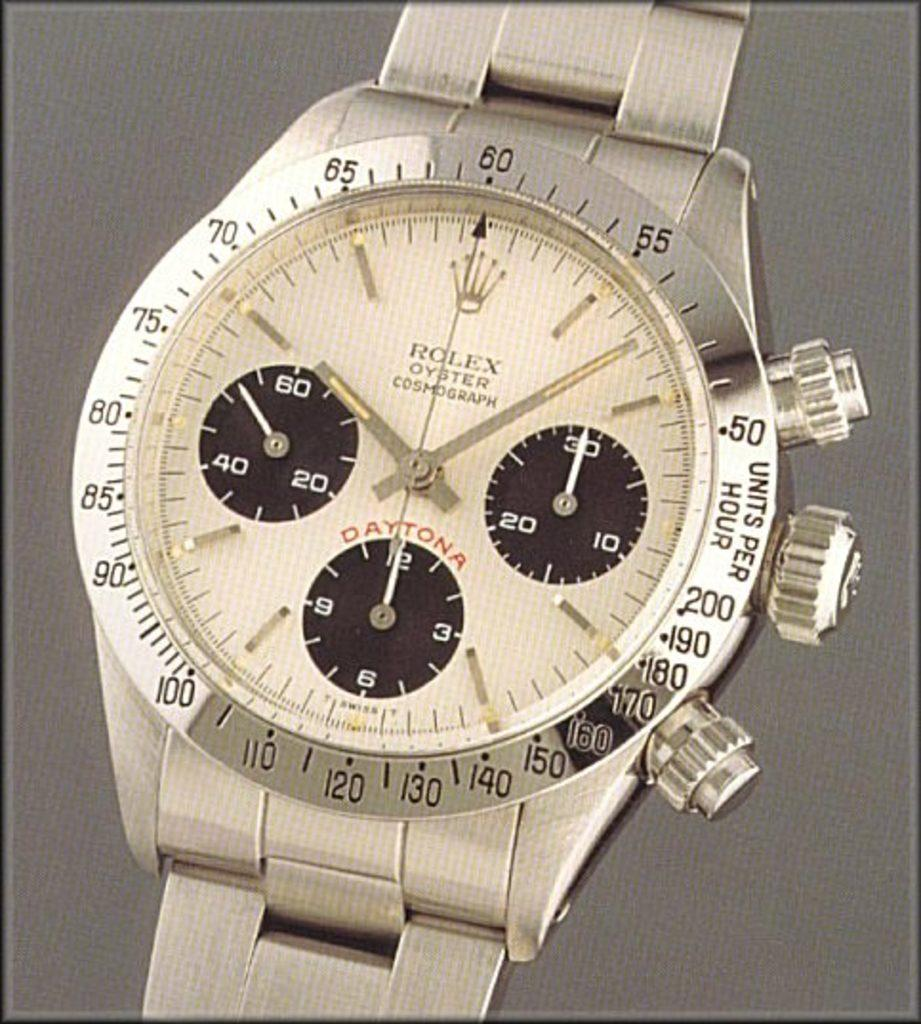<image>
Render a clear and concise summary of the photo. Rolex sits against a gray back ground and shows you the units per hour. 